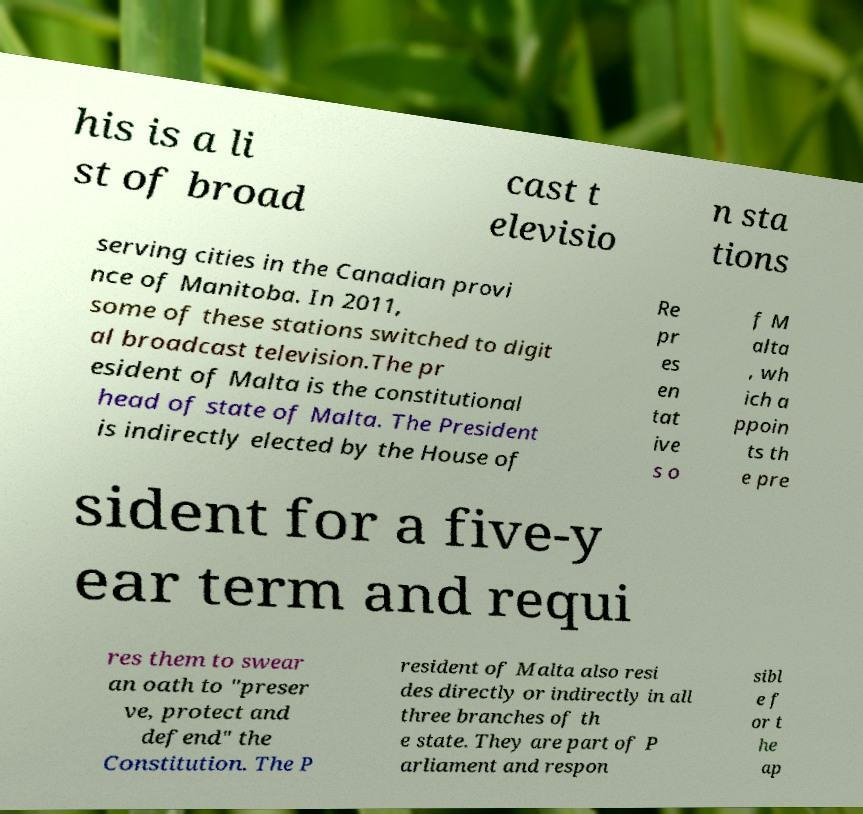Could you extract and type out the text from this image? his is a li st of broad cast t elevisio n sta tions serving cities in the Canadian provi nce of Manitoba. In 2011, some of these stations switched to digit al broadcast television.The pr esident of Malta is the constitutional head of state of Malta. The President is indirectly elected by the House of Re pr es en tat ive s o f M alta , wh ich a ppoin ts th e pre sident for a five-y ear term and requi res them to swear an oath to "preser ve, protect and defend" the Constitution. The P resident of Malta also resi des directly or indirectly in all three branches of th e state. They are part of P arliament and respon sibl e f or t he ap 